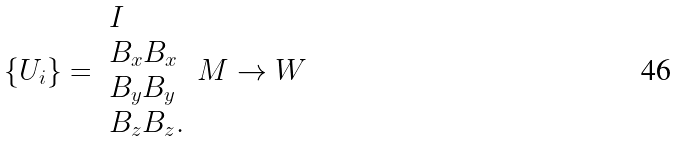Convert formula to latex. <formula><loc_0><loc_0><loc_500><loc_500>\{ U _ { i } \} = \begin{array} { l } I \\ B _ { x } B _ { x } \\ B _ { y } B _ { y } \\ B _ { z } B _ { z } . \end{array} \, M \rightarrow W</formula> 